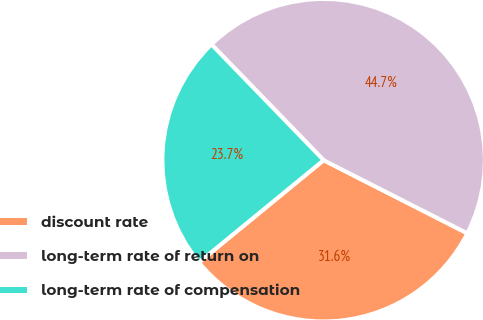Convert chart to OTSL. <chart><loc_0><loc_0><loc_500><loc_500><pie_chart><fcel>discount rate<fcel>long-term rate of return on<fcel>long-term rate of compensation<nl><fcel>31.58%<fcel>44.74%<fcel>23.68%<nl></chart> 